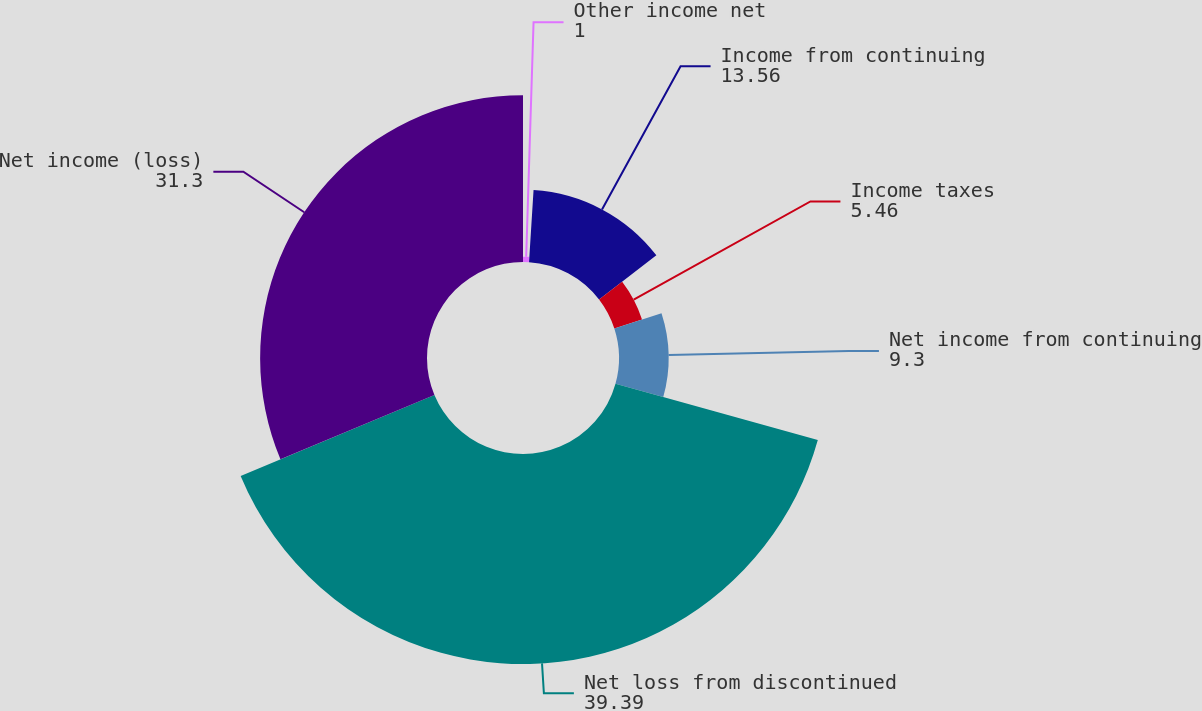<chart> <loc_0><loc_0><loc_500><loc_500><pie_chart><fcel>Other income net<fcel>Income from continuing<fcel>Income taxes<fcel>Net income from continuing<fcel>Net loss from discontinued<fcel>Net income (loss)<nl><fcel>1.0%<fcel>13.56%<fcel>5.46%<fcel>9.3%<fcel>39.39%<fcel>31.3%<nl></chart> 